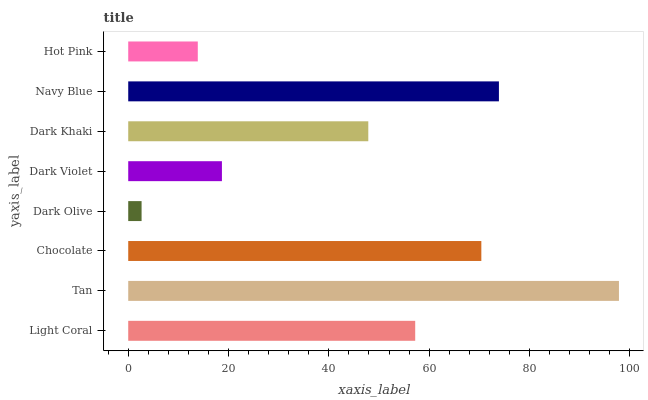Is Dark Olive the minimum?
Answer yes or no. Yes. Is Tan the maximum?
Answer yes or no. Yes. Is Chocolate the minimum?
Answer yes or no. No. Is Chocolate the maximum?
Answer yes or no. No. Is Tan greater than Chocolate?
Answer yes or no. Yes. Is Chocolate less than Tan?
Answer yes or no. Yes. Is Chocolate greater than Tan?
Answer yes or no. No. Is Tan less than Chocolate?
Answer yes or no. No. Is Light Coral the high median?
Answer yes or no. Yes. Is Dark Khaki the low median?
Answer yes or no. Yes. Is Dark Khaki the high median?
Answer yes or no. No. Is Navy Blue the low median?
Answer yes or no. No. 